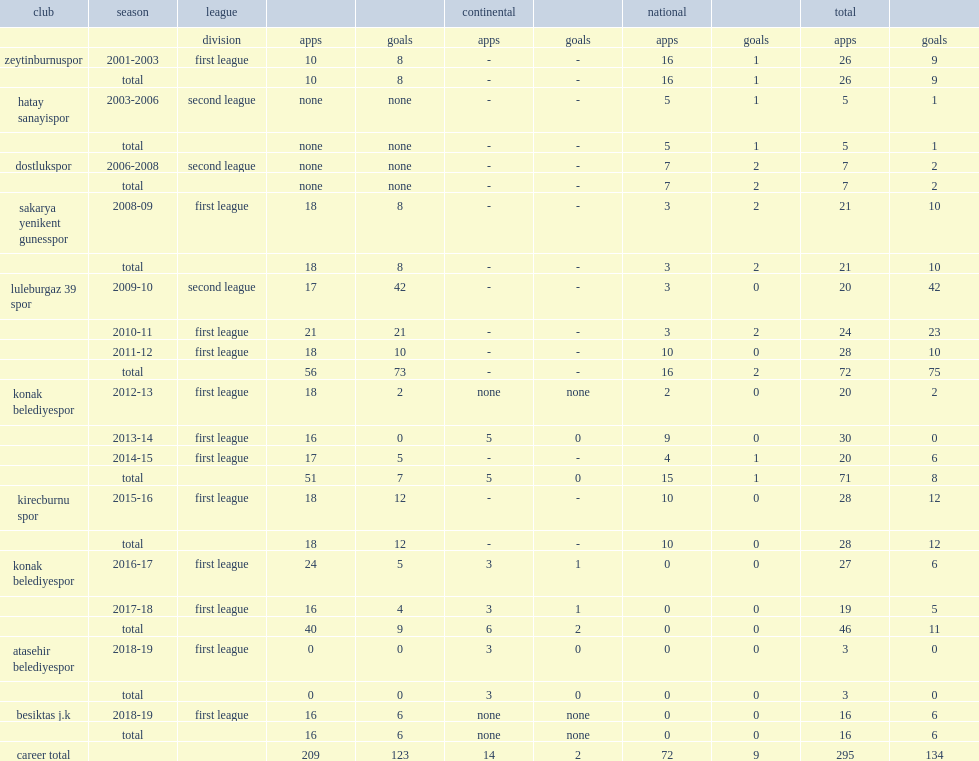For the 2015-16 season, which club did esra erol join in the first league? Kirecburnu spor. 